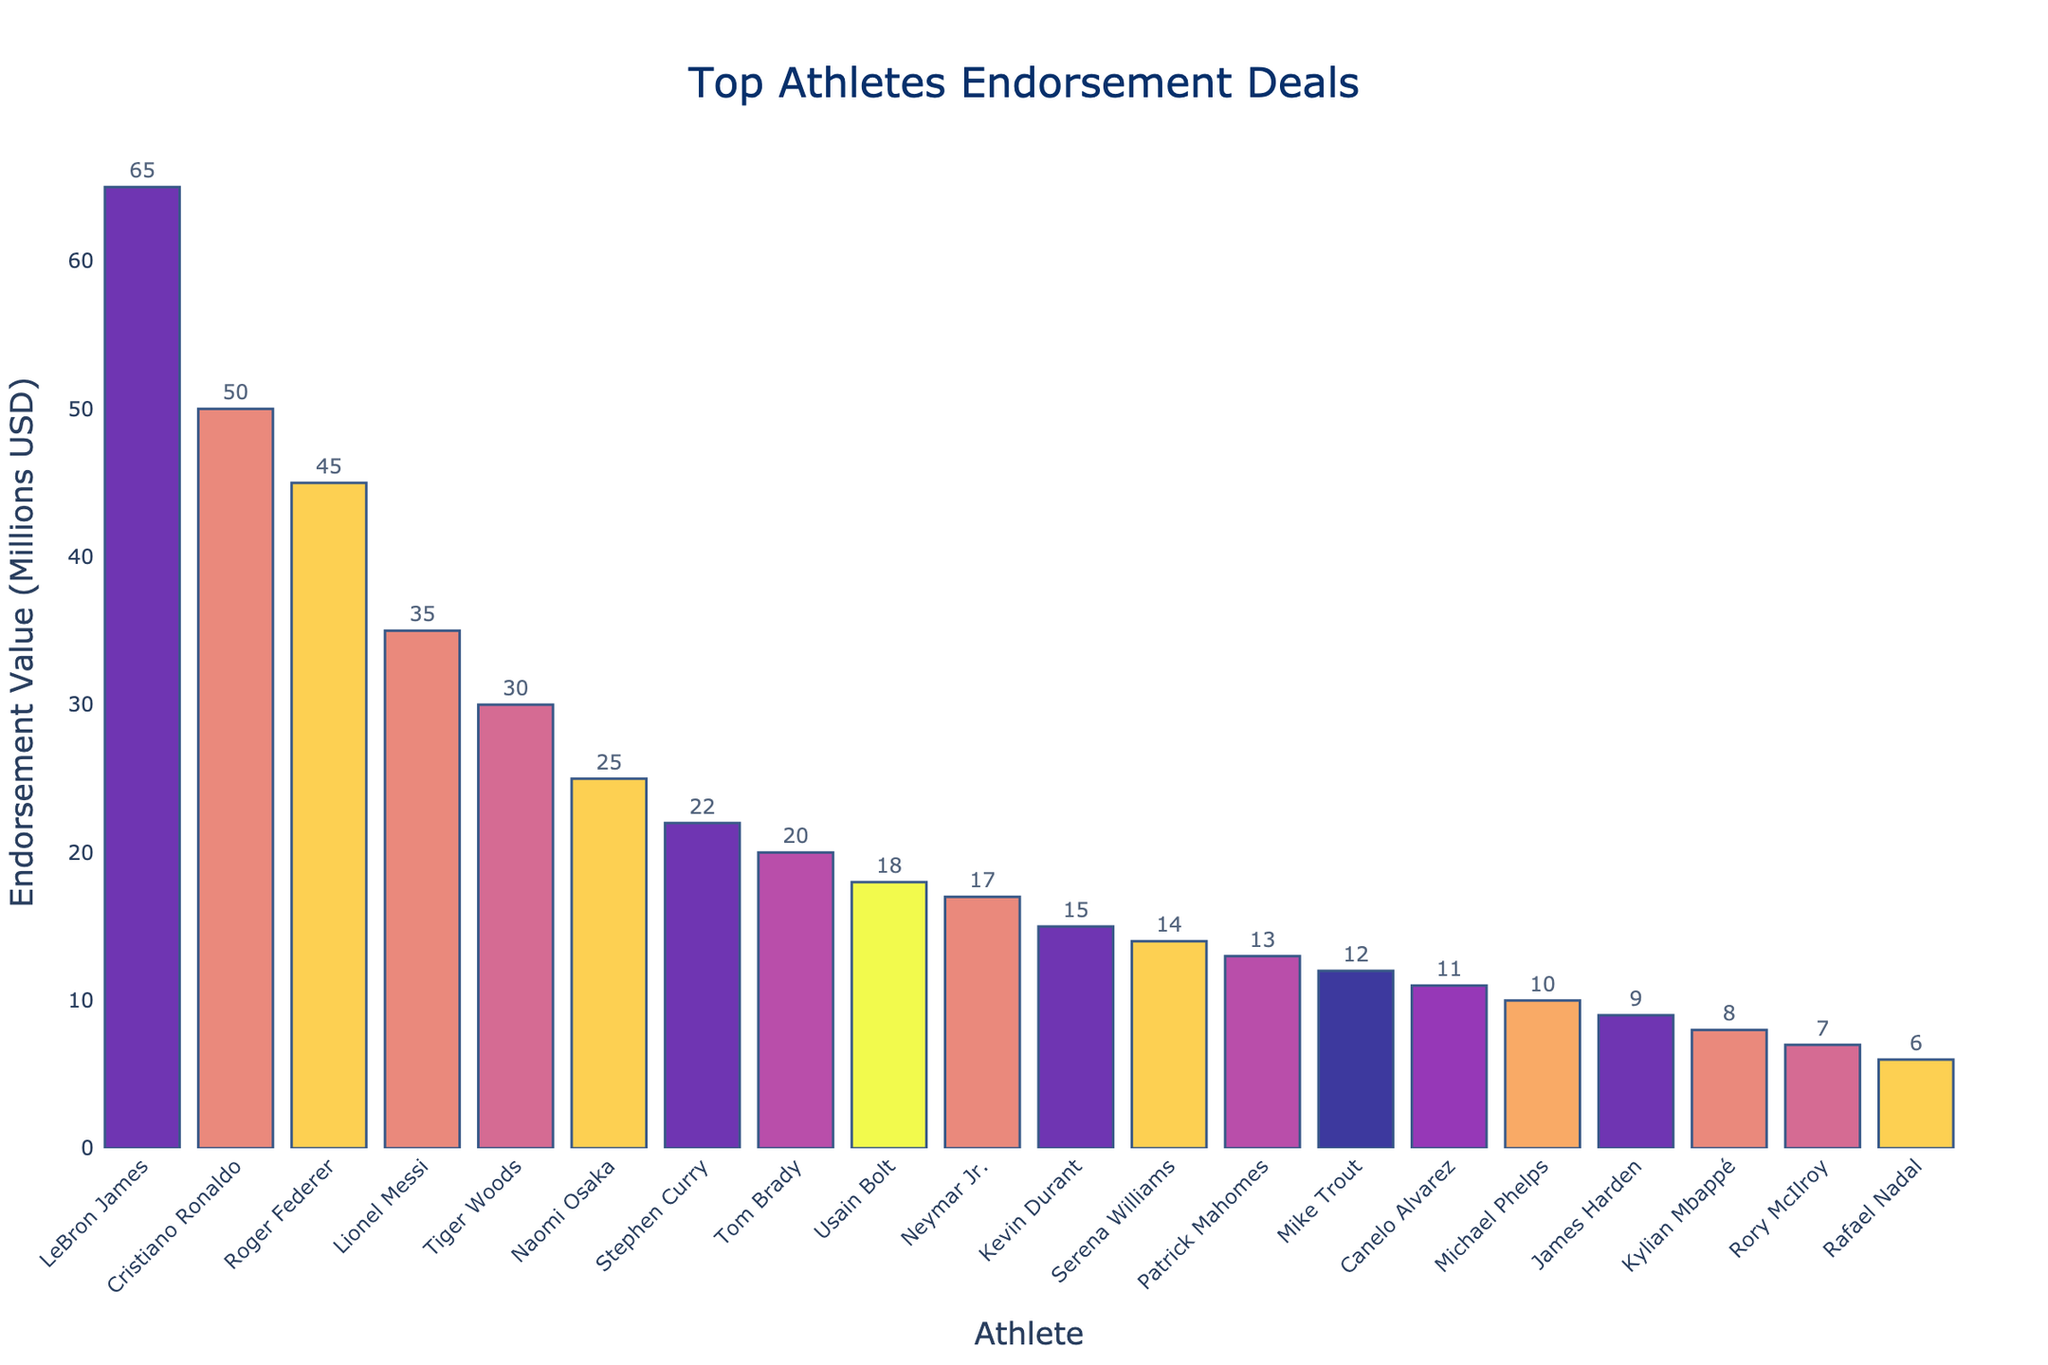What's the total endorsement value for basketball athletes? To find the total endorsement value for basketball athletes, sum up the values for LeBron James, Stephen Curry, Kevin Durant, and James Harden. The individual endorsement values are 65 + 22 + 15 + 9 = 111 million USD.
Answer: 111 million USD Which athlete has the highest endorsement value and in which sport? By looking at the height of the bars, LeBron James has the tallest bar, indicating he has the highest endorsement value. His sport is identified as basketball.
Answer: LeBron James, Basketball What's the difference in endorsement values between the top soccer player and the top basketball player? The top soccer player is Cristiano Ronaldo with an endorsement value of 50 million USD, and the top basketball player is LeBron James with 65 million USD. The difference is 65 - 50 = 15 million USD.
Answer: 15 million USD Which sport has the most athletes among the top 20 endorsement deals? By examining the text labels, basketball and soccer each appear multiple times. Counting the occurrences for each sport, basketball appears 4 times (LeBron James, Stephen Curry, Kevin Durant, James Harden) and soccer appears 4 times (Cristiano Ronaldo, Lionel Messi, Neymar Jr., Kylian Mbappé). Both sports have the most athletes in the top 20.
Answer: Basketball and Soccer What is the combined endorsement value for all athletes in soccer? To find the combined endorsement value for soccer athletes, sum up the values for Cristiano Ronaldo (50), Lionel Messi (35), Neymar Jr. (17), and Kylian Mbappé (8). The total is 50 + 35 + 17 + 8 = 110 million USD.
Answer: 110 million USD Which athlete in tennis has the lowest endorsement value, and what is it? By inspecting the bars for tennis, Rafael Nadal has the smallest bar among tennis athletes, indicating the lowest endorsement value. His endorsement value is 6 million USD.
Answer: Rafael Nadal, 6 million USD How much higher is the endorsement value of Tiger Woods compared to Rory McIlroy? By checking the endorsement values for both golfers, Tiger Woods has an endorsement value of 30 million USD, and Rory McIlroy has 7 million USD. The difference is 30 - 7 = 23 million USD.
Answer: 23 million USD Which female athlete has the highest endorsement value and what sport does she represent? By observing the text labels and bars, Naomi Osaka has the highest endorsement value among female athletes at 25 million USD, and she represents tennis.
Answer: Naomi Osaka, Tennis Between Roger Federer and Serena Williams, who has the higher endorsement value, and by how much? Roger Federer has an endorsement value of 45 million USD, while Serena Williams has 14 million USD. The difference is 45 - 14 = 31 million USD, with Federer having the higher value.
Answer: Roger Federer, 31 million USD What is the average endorsement value of the top 5 athletes? To find the average, sum up the endorsement values of LeBron James (65), Cristiano Ronaldo (50), Roger Federer (45), Lionel Messi (35), and Tiger Woods (30). The sum is 65 + 50 + 45 + 35 + 30 = 225. Divide by 5 to get the average, 225 / 5 = 45 million USD.
Answer: 45 million USD 